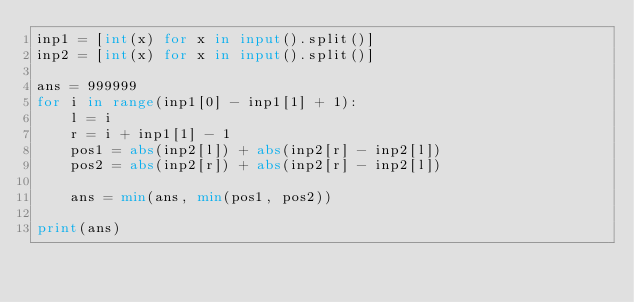Convert code to text. <code><loc_0><loc_0><loc_500><loc_500><_Python_>inp1 = [int(x) for x in input().split()]
inp2 = [int(x) for x in input().split()]

ans = 999999
for i in range(inp1[0] - inp1[1] + 1):
    l = i
    r = i + inp1[1] - 1
    pos1 = abs(inp2[l]) + abs(inp2[r] - inp2[l])
    pos2 = abs(inp2[r]) + abs(inp2[r] - inp2[l])
    
    ans = min(ans, min(pos1, pos2))
    
print(ans)
    </code> 